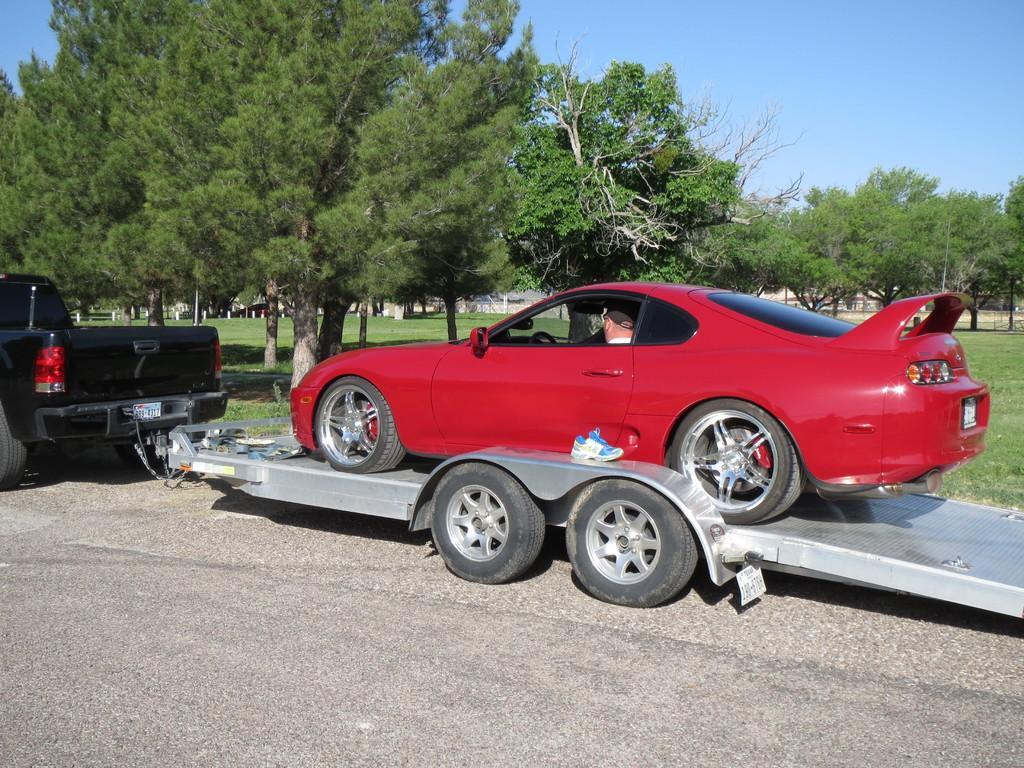Please provide a concise description of this image. In this image we can see a vehicle on the road and there is a car on the ramp, a person sitting in the car and there are few objects on the ramp, there are few trees and the sky in the background. 